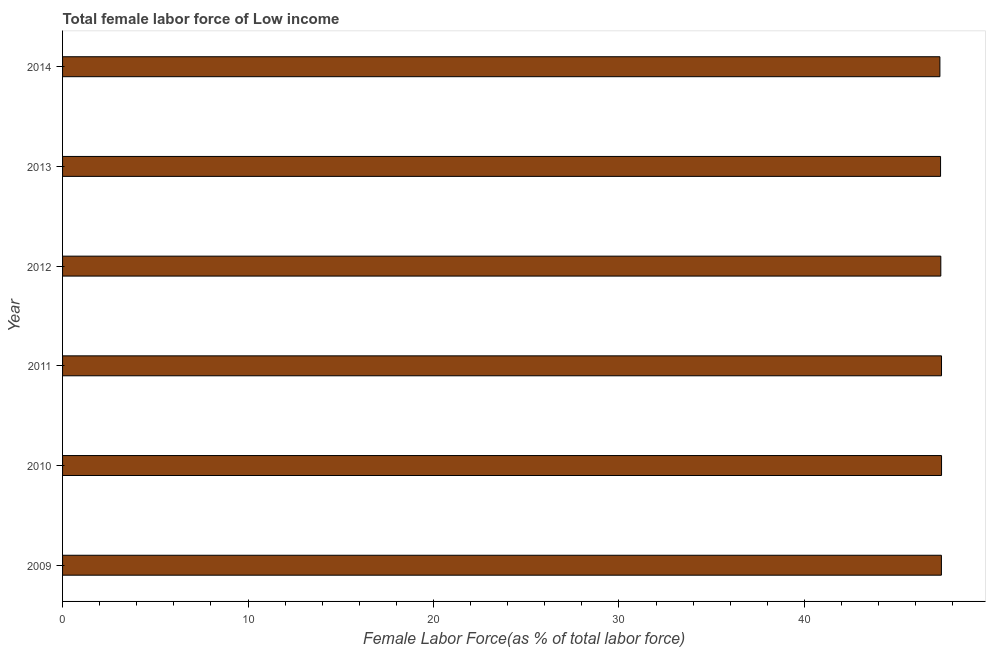Does the graph contain any zero values?
Offer a very short reply. No. Does the graph contain grids?
Offer a terse response. No. What is the title of the graph?
Keep it short and to the point. Total female labor force of Low income. What is the label or title of the X-axis?
Provide a short and direct response. Female Labor Force(as % of total labor force). What is the label or title of the Y-axis?
Offer a terse response. Year. What is the total female labor force in 2009?
Offer a very short reply. 47.39. Across all years, what is the maximum total female labor force?
Your answer should be very brief. 47.39. Across all years, what is the minimum total female labor force?
Give a very brief answer. 47.31. In which year was the total female labor force maximum?
Your answer should be very brief. 2010. In which year was the total female labor force minimum?
Offer a very short reply. 2014. What is the sum of the total female labor force?
Provide a short and direct response. 284.18. What is the difference between the total female labor force in 2009 and 2012?
Your answer should be very brief. 0.03. What is the average total female labor force per year?
Ensure brevity in your answer.  47.36. What is the median total female labor force?
Your answer should be very brief. 47.37. In how many years, is the total female labor force greater than 4 %?
Keep it short and to the point. 6. Do a majority of the years between 2010 and 2012 (inclusive) have total female labor force greater than 42 %?
Offer a very short reply. Yes. What is the ratio of the total female labor force in 2011 to that in 2014?
Keep it short and to the point. 1. Is the total female labor force in 2010 less than that in 2014?
Keep it short and to the point. No. Is the difference between the total female labor force in 2009 and 2014 greater than the difference between any two years?
Provide a succinct answer. No. What is the difference between the highest and the second highest total female labor force?
Provide a short and direct response. 0. Is the sum of the total female labor force in 2010 and 2013 greater than the maximum total female labor force across all years?
Your response must be concise. Yes. What is the difference between the highest and the lowest total female labor force?
Your answer should be very brief. 0.09. Are the values on the major ticks of X-axis written in scientific E-notation?
Your answer should be compact. No. What is the Female Labor Force(as % of total labor force) of 2009?
Offer a very short reply. 47.39. What is the Female Labor Force(as % of total labor force) of 2010?
Offer a terse response. 47.39. What is the Female Labor Force(as % of total labor force) of 2011?
Provide a succinct answer. 47.39. What is the Female Labor Force(as % of total labor force) in 2012?
Your answer should be very brief. 47.36. What is the Female Labor Force(as % of total labor force) in 2013?
Provide a short and direct response. 47.34. What is the Female Labor Force(as % of total labor force) in 2014?
Offer a terse response. 47.31. What is the difference between the Female Labor Force(as % of total labor force) in 2009 and 2010?
Provide a short and direct response. -0.01. What is the difference between the Female Labor Force(as % of total labor force) in 2009 and 2011?
Keep it short and to the point. -0.01. What is the difference between the Female Labor Force(as % of total labor force) in 2009 and 2012?
Offer a terse response. 0.03. What is the difference between the Female Labor Force(as % of total labor force) in 2009 and 2013?
Ensure brevity in your answer.  0.05. What is the difference between the Female Labor Force(as % of total labor force) in 2009 and 2014?
Offer a very short reply. 0.08. What is the difference between the Female Labor Force(as % of total labor force) in 2010 and 2011?
Your answer should be very brief. 0. What is the difference between the Female Labor Force(as % of total labor force) in 2010 and 2012?
Provide a succinct answer. 0.04. What is the difference between the Female Labor Force(as % of total labor force) in 2010 and 2013?
Keep it short and to the point. 0.05. What is the difference between the Female Labor Force(as % of total labor force) in 2010 and 2014?
Ensure brevity in your answer.  0.09. What is the difference between the Female Labor Force(as % of total labor force) in 2011 and 2012?
Ensure brevity in your answer.  0.04. What is the difference between the Female Labor Force(as % of total labor force) in 2011 and 2013?
Your answer should be very brief. 0.05. What is the difference between the Female Labor Force(as % of total labor force) in 2011 and 2014?
Make the answer very short. 0.09. What is the difference between the Female Labor Force(as % of total labor force) in 2012 and 2013?
Your answer should be compact. 0.01. What is the difference between the Female Labor Force(as % of total labor force) in 2012 and 2014?
Provide a short and direct response. 0.05. What is the difference between the Female Labor Force(as % of total labor force) in 2013 and 2014?
Your answer should be very brief. 0.04. What is the ratio of the Female Labor Force(as % of total labor force) in 2009 to that in 2010?
Offer a terse response. 1. What is the ratio of the Female Labor Force(as % of total labor force) in 2009 to that in 2012?
Give a very brief answer. 1. What is the ratio of the Female Labor Force(as % of total labor force) in 2009 to that in 2013?
Offer a very short reply. 1. What is the ratio of the Female Labor Force(as % of total labor force) in 2010 to that in 2011?
Give a very brief answer. 1. What is the ratio of the Female Labor Force(as % of total labor force) in 2010 to that in 2013?
Your response must be concise. 1. What is the ratio of the Female Labor Force(as % of total labor force) in 2011 to that in 2013?
Your answer should be very brief. 1. What is the ratio of the Female Labor Force(as % of total labor force) in 2011 to that in 2014?
Offer a very short reply. 1. What is the ratio of the Female Labor Force(as % of total labor force) in 2012 to that in 2013?
Your answer should be compact. 1. What is the ratio of the Female Labor Force(as % of total labor force) in 2013 to that in 2014?
Provide a short and direct response. 1. 